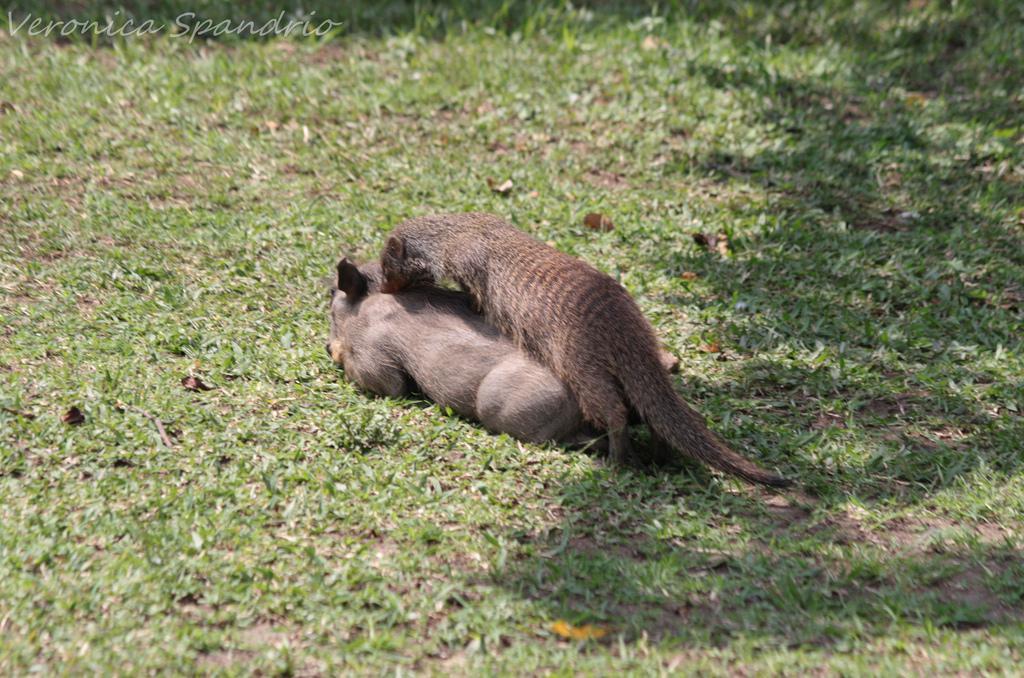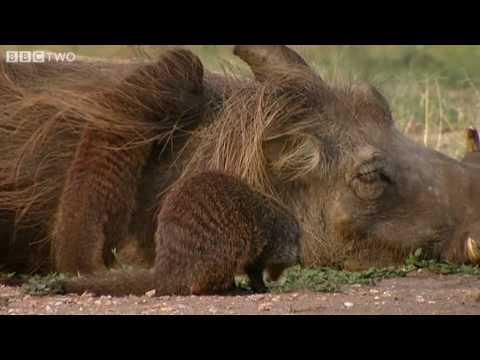The first image is the image on the left, the second image is the image on the right. Given the left and right images, does the statement "the right pic has three or less animals" hold true? Answer yes or no. Yes. The first image is the image on the left, the second image is the image on the right. Assess this claim about the two images: "There is, at most, one warthog on a dirt ground.". Correct or not? Answer yes or no. No. 